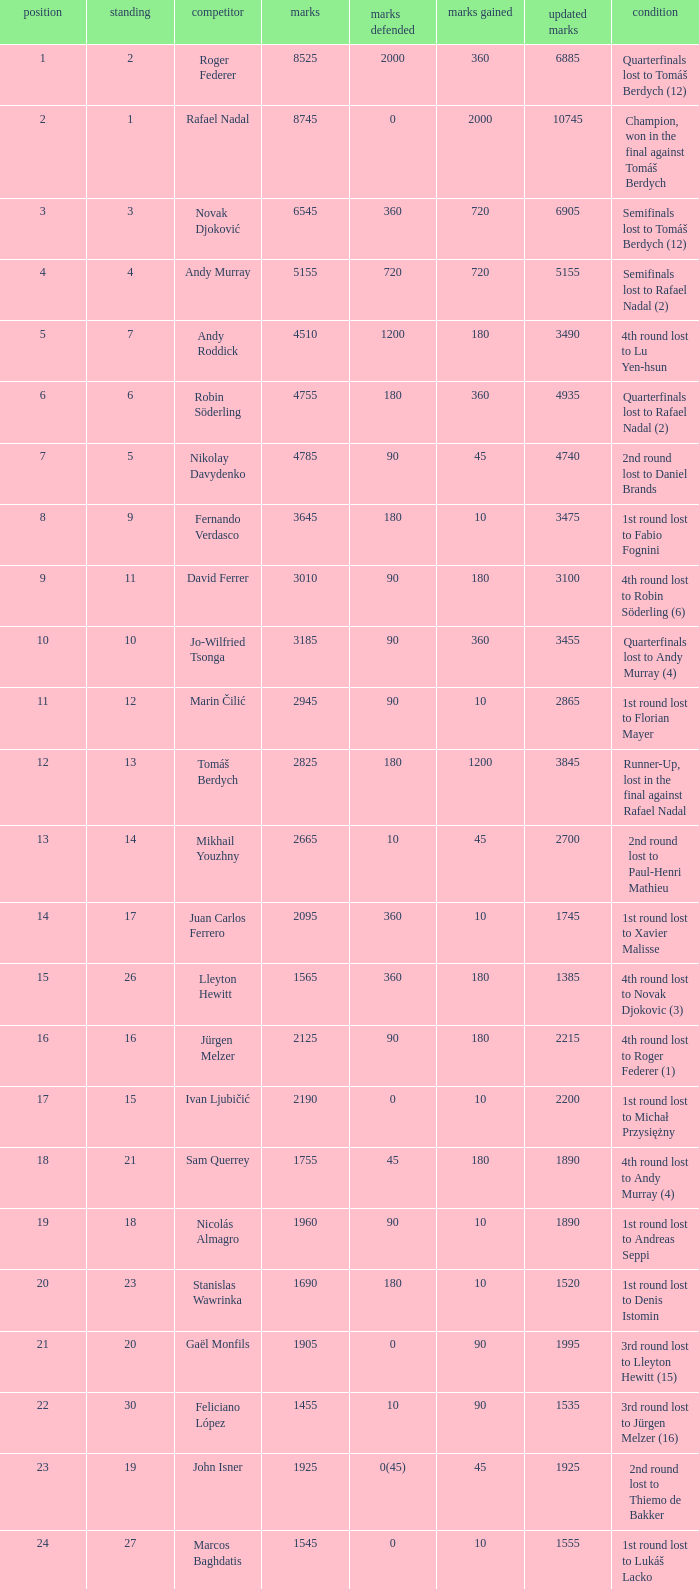Name the status for points 3185 Quarterfinals lost to Andy Murray (4). 